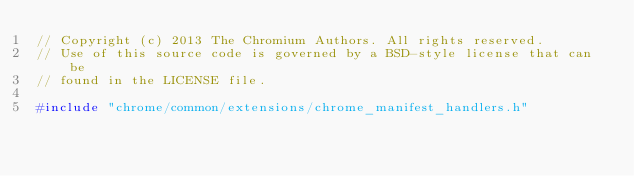<code> <loc_0><loc_0><loc_500><loc_500><_C++_>// Copyright (c) 2013 The Chromium Authors. All rights reserved.
// Use of this source code is governed by a BSD-style license that can be
// found in the LICENSE file.

#include "chrome/common/extensions/chrome_manifest_handlers.h"
</code> 